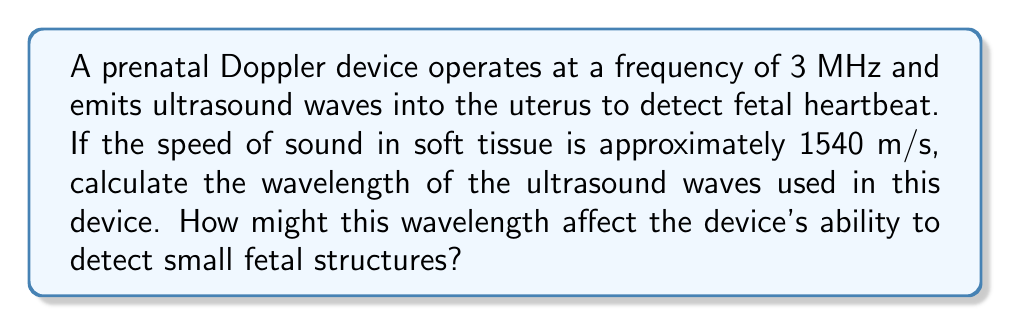Could you help me with this problem? To solve this problem, we'll use the wave equation that relates wave speed, frequency, and wavelength:

$$v = f \lambda$$

Where:
$v$ = wave speed (m/s)
$f$ = frequency (Hz)
$\lambda$ = wavelength (m)

Given:
- Frequency, $f = 3 \text{ MHz} = 3 \times 10^6 \text{ Hz}$
- Speed of sound in soft tissue, $v = 1540 \text{ m/s}$

Step 1: Rearrange the wave equation to solve for wavelength:
$$\lambda = \frac{v}{f}$$

Step 2: Substitute the known values and calculate:
$$\lambda = \frac{1540 \text{ m/s}}{3 \times 10^6 \text{ Hz}} = 5.13 \times 10^{-4} \text{ m} = 0.513 \text{ mm}$$

Step 3: Interpret the result:
The wavelength of 0.513 mm is relatively small, which allows the prenatal Doppler device to detect fine structures within the fetus. Generally, structures smaller than the wavelength are difficult to resolve. This wavelength is suitable for detecting the fetal heartbeat and other small fetal structures, making it effective for prenatal monitoring.
Answer: $\lambda = 0.513 \text{ mm}$ 